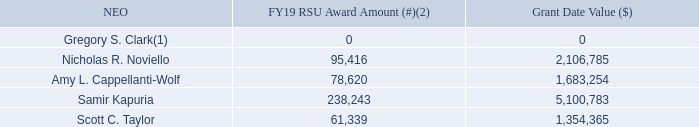Restricted Stock Units (RSUs): RSUs represent the right to receive one share of NortonLifeLock common stock for each vested RSU upon the settlement date, subject to continued employment through each vesting date.
(1) Mr. Clark did not receive an RSU award for FY19.
(2) In FY19, Messrs. Taylor and Noviello, as FY18 NEOs, were granted a mix of PRUs and RSUs at 70% and 30%, respectively. All other executives, other than Mr. Clark, received a mix of PRUs and RSUs at 50% and 50%, respectively.
What does RSU stand for? Restricted stock units. What is the right to receive one share of NortonLifeLock common stock for each vested RSU upon the settlement date subjected to? Continued employment through each vesting date. What is Scott C. Taylor's FY19 RSU award amount? 61,339. What is the total grant date value for all NEOs? 0+2,106,785+1,683,254+5,100,783+1,354,365
Answer: 10245187. Which NEO has the highest amount of FY19 RSU Award Amount? 238,243>95,416> 78,620>61,339>0
Answer: samir kapuria. How much more in grant date value does Nicholas R. Noviello have compared to Amy L. Cappellanti-Wolf? 2,106,785-1,683,254
Answer: 423531. 